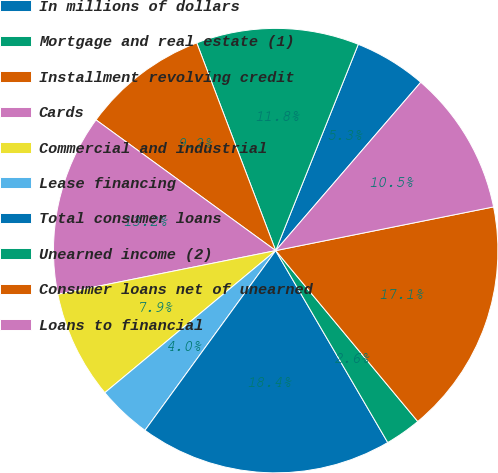Convert chart to OTSL. <chart><loc_0><loc_0><loc_500><loc_500><pie_chart><fcel>In millions of dollars<fcel>Mortgage and real estate (1)<fcel>Installment revolving credit<fcel>Cards<fcel>Commercial and industrial<fcel>Lease financing<fcel>Total consumer loans<fcel>Unearned income (2)<fcel>Consumer loans net of unearned<fcel>Loans to financial<nl><fcel>5.26%<fcel>11.84%<fcel>9.21%<fcel>13.16%<fcel>7.89%<fcel>3.95%<fcel>18.42%<fcel>2.63%<fcel>17.11%<fcel>10.53%<nl></chart> 